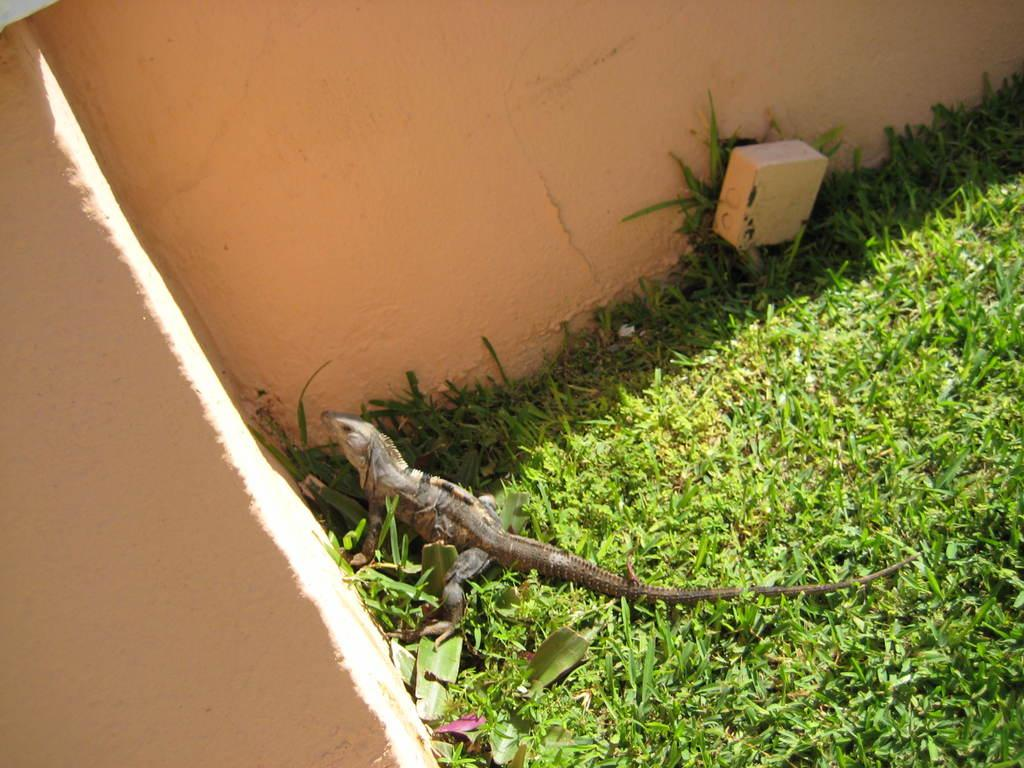What type of vegetation can be seen in the image? There is grass in the image. What type of animal is present in the image? There is a reptile in the image. What structure can be seen in the image? There is a wall in the image. What type of beef is being cooked on the grill in the image? There is no grill or beef present in the image; it features grass, a reptile, and a wall. What is the reptile doing to its throat in the image? There is no indication of the reptile interacting with its throat in the image. 